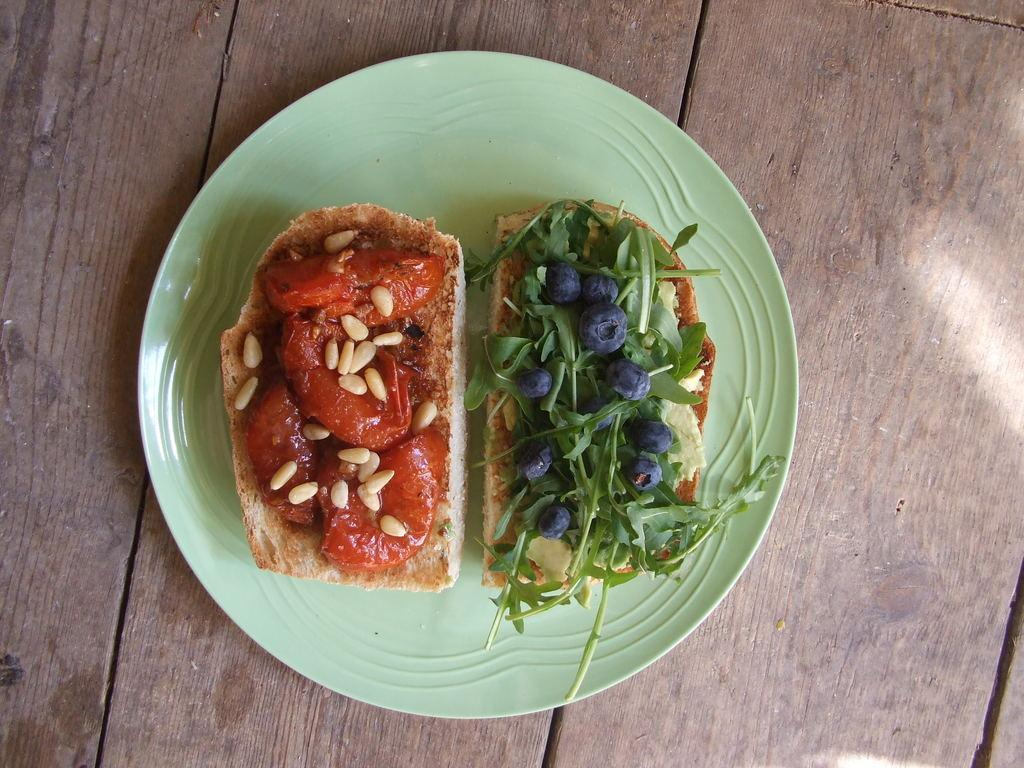What is on the plate that is visible in the image? There is food in a plate in the image. Where is the plate located? The plate is on a wooden platform. How many roses are on the plate in the image? There are no roses present on the plate in the image; it contains food. 